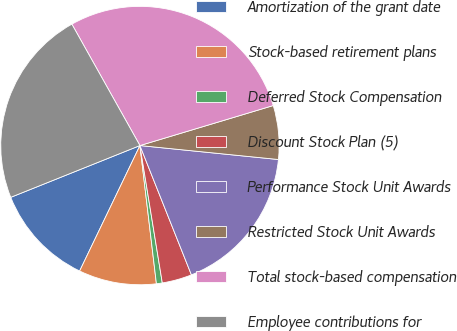Convert chart to OTSL. <chart><loc_0><loc_0><loc_500><loc_500><pie_chart><fcel>Amortization of the grant date<fcel>Stock-based retirement plans<fcel>Deferred Stock Compensation<fcel>Discount Stock Plan (5)<fcel>Performance Stock Unit Awards<fcel>Restricted Stock Unit Awards<fcel>Total stock-based compensation<fcel>Employee contributions for<nl><fcel>11.8%<fcel>9.02%<fcel>0.68%<fcel>3.46%<fcel>17.37%<fcel>6.24%<fcel>28.49%<fcel>22.93%<nl></chart> 